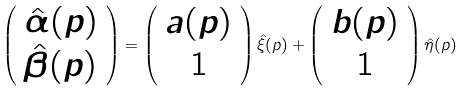Convert formula to latex. <formula><loc_0><loc_0><loc_500><loc_500>\left ( \begin{array} { c c } { { \hat { \alpha } ( p ) } } \\ { { \hat { \beta } ( p ) } } \end{array} \right ) = \left ( \begin{array} { c c } { a ( p ) } \\ { 1 } \end{array} \right ) \hat { \xi } ( p ) + \left ( \begin{array} { c c } { b ( p ) } \\ { 1 } \end{array} \right ) \hat { \eta } ( p )</formula> 